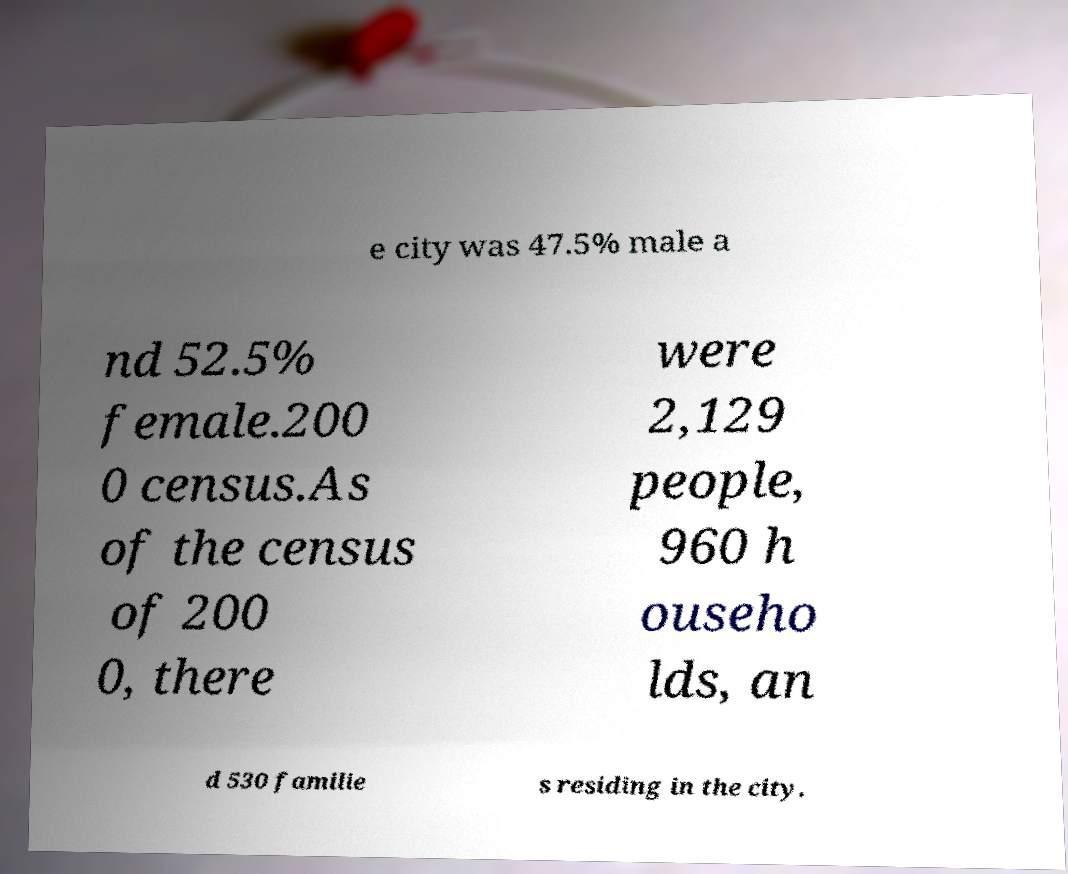Can you read and provide the text displayed in the image?This photo seems to have some interesting text. Can you extract and type it out for me? e city was 47.5% male a nd 52.5% female.200 0 census.As of the census of 200 0, there were 2,129 people, 960 h ouseho lds, an d 530 familie s residing in the city. 